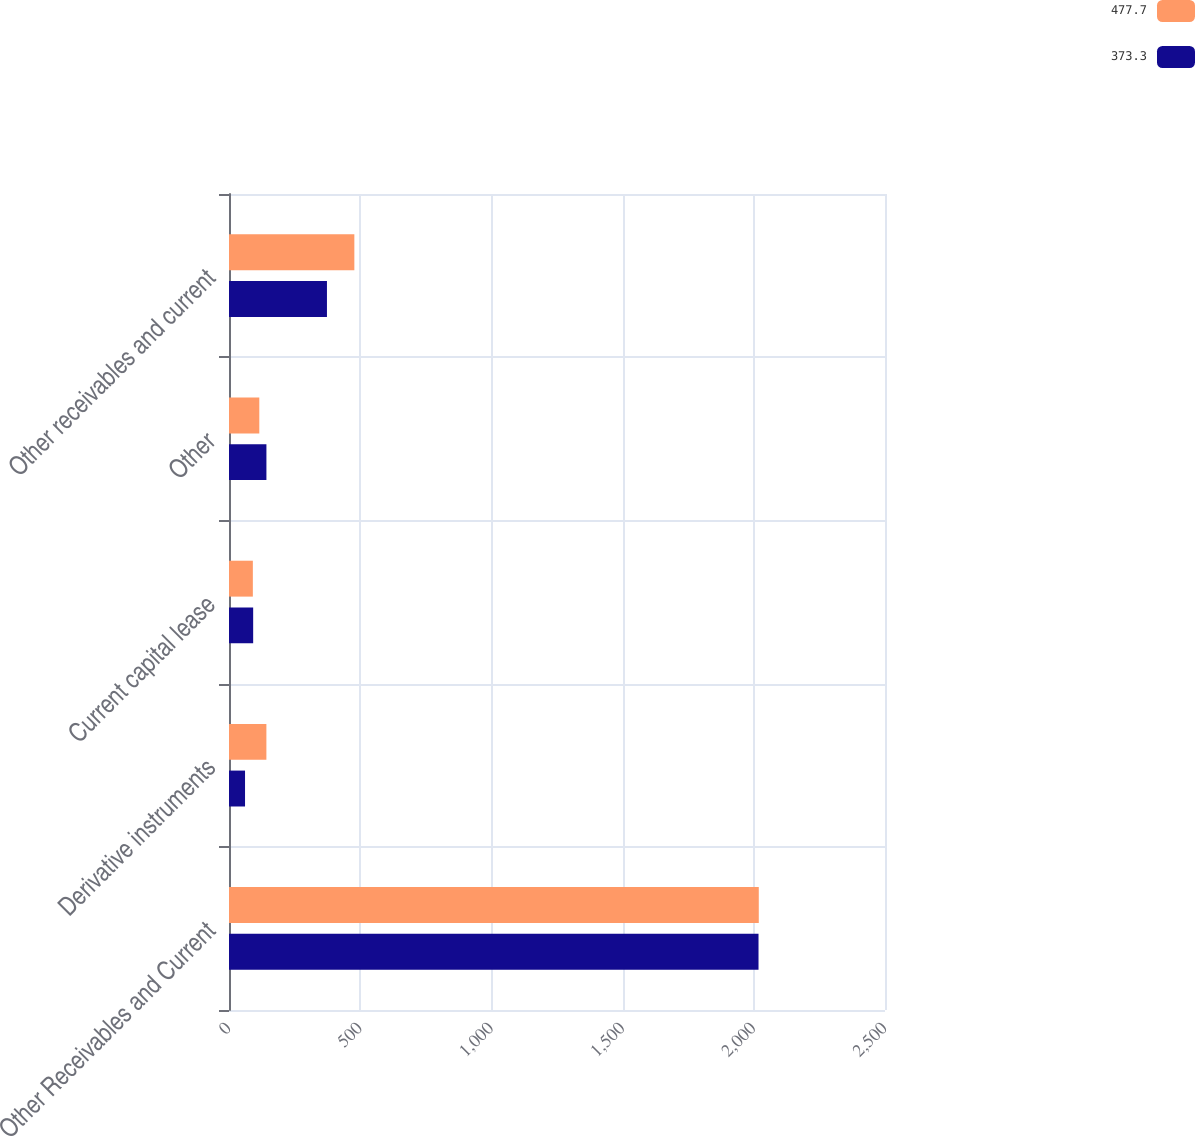Convert chart. <chart><loc_0><loc_0><loc_500><loc_500><stacked_bar_chart><ecel><fcel>Other Receivables and Current<fcel>Derivative instruments<fcel>Current capital lease<fcel>Other<fcel>Other receivables and current<nl><fcel>477.7<fcel>2019<fcel>142.5<fcel>90.9<fcel>115.5<fcel>477.7<nl><fcel>373.3<fcel>2018<fcel>61.1<fcel>92.1<fcel>142.6<fcel>373.3<nl></chart> 